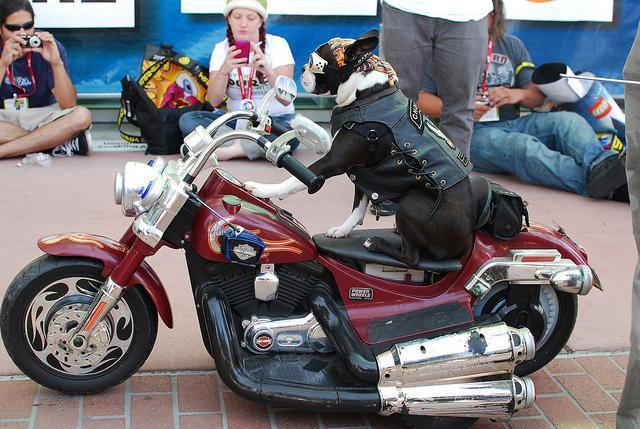How many wheels does this thing have?
Give a very brief answer. 2. How many people are in the picture?
Give a very brief answer. 4. How many bikes are visible?
Give a very brief answer. 1. How many people are there?
Give a very brief answer. 4. How many horses are looking at the camera?
Give a very brief answer. 0. 